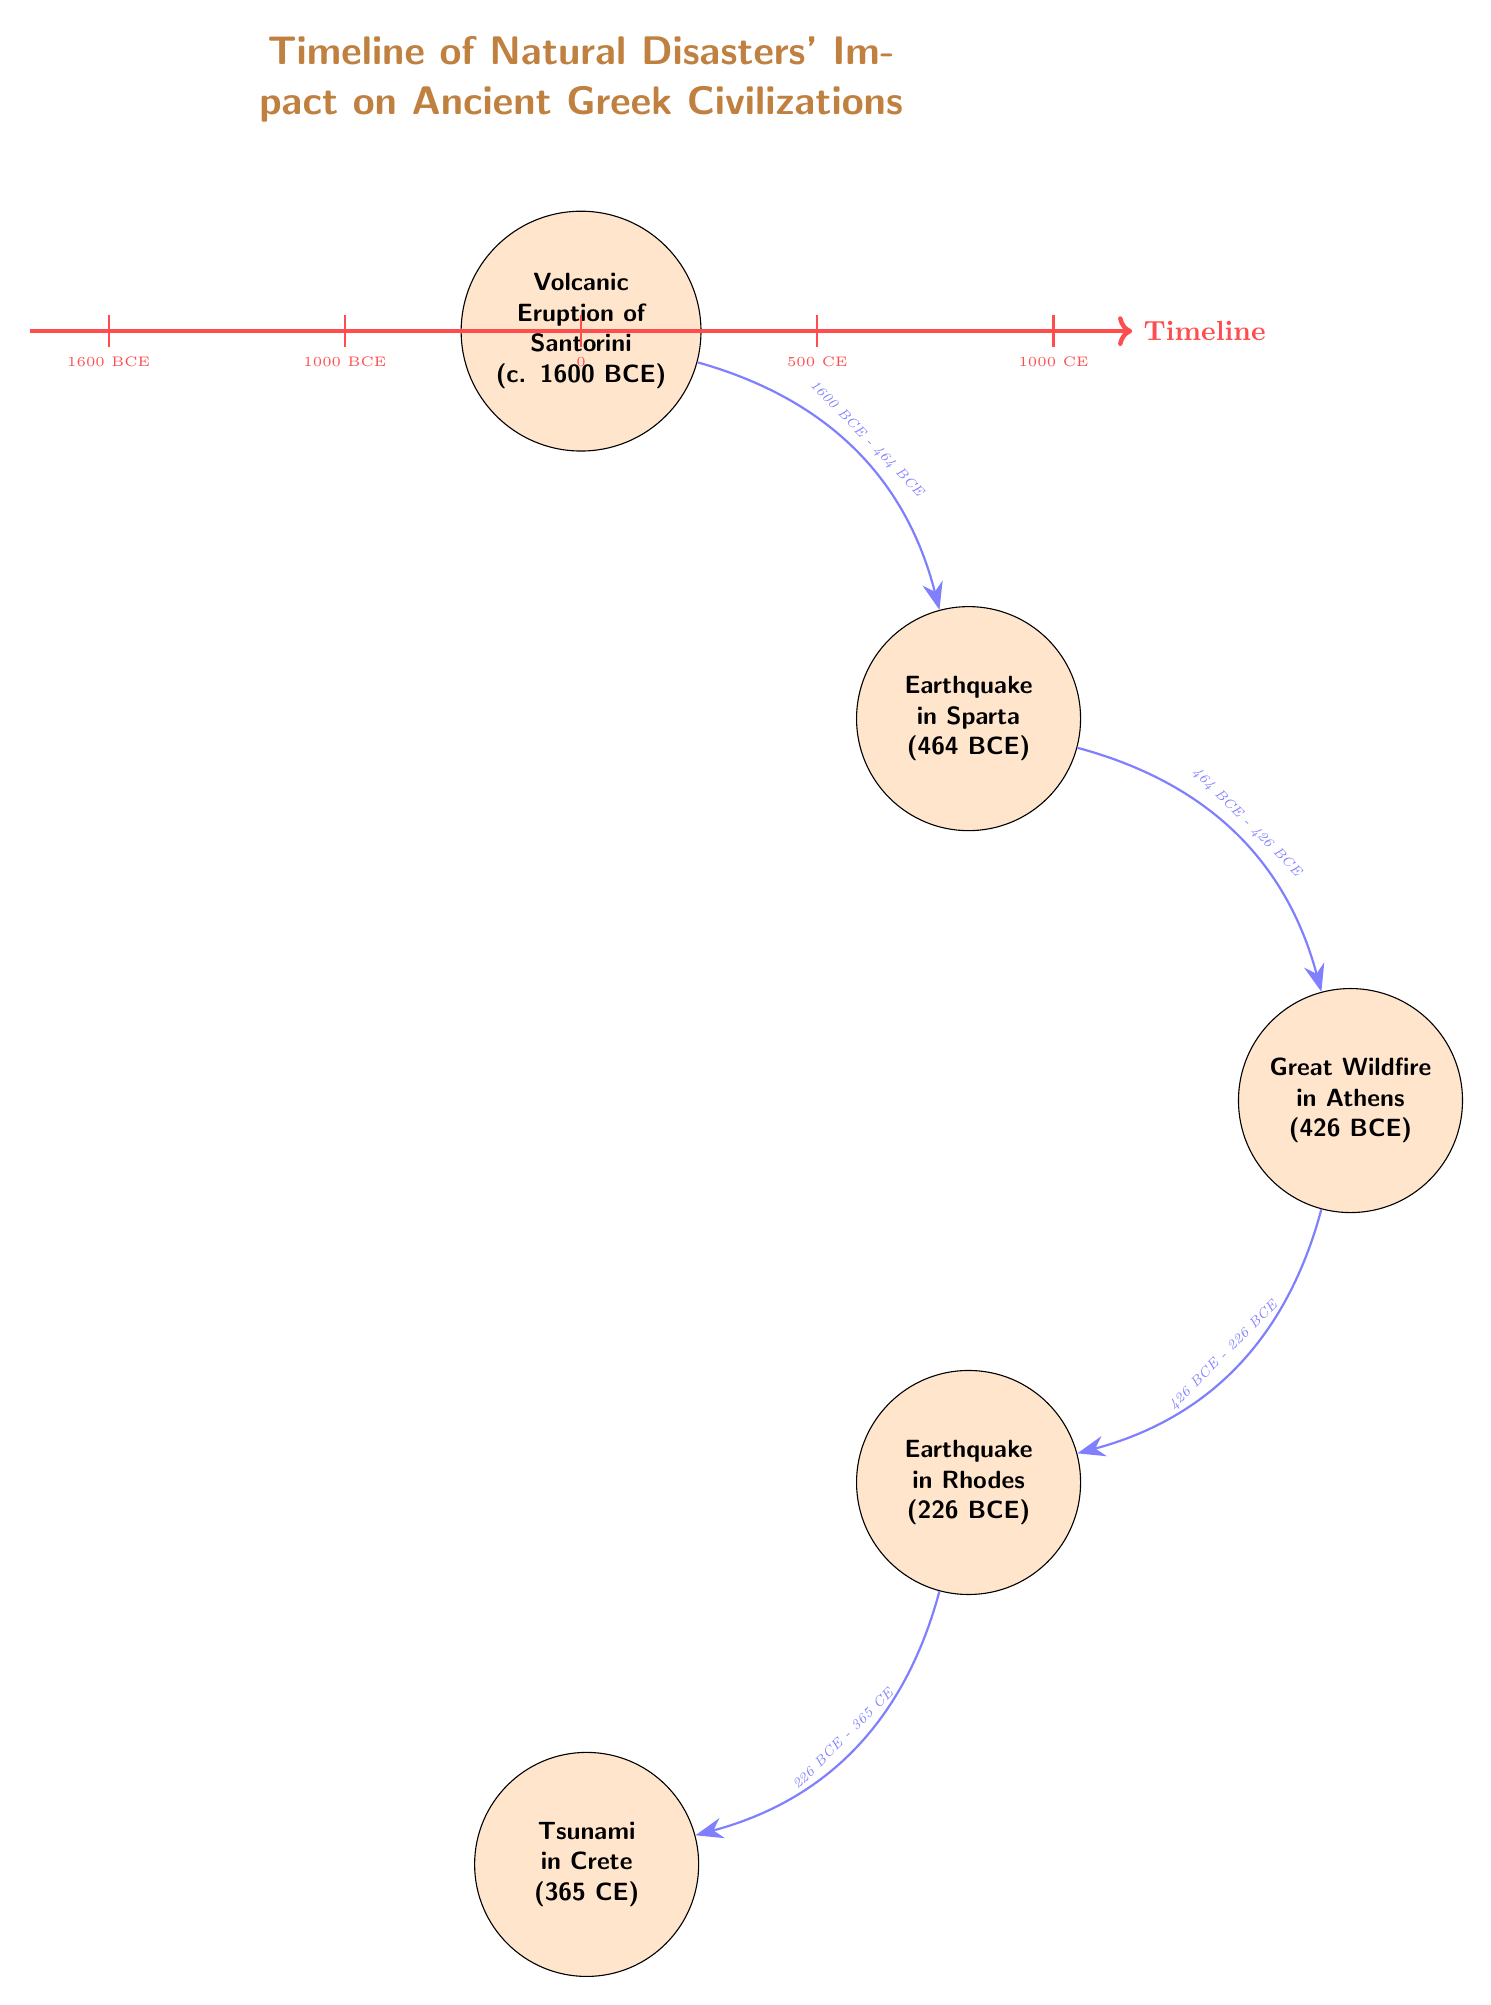What is the event depicted at c. 1600 BCE? The diagram shows a node labeled "Volcanic Eruption of Santorini" at the position corresponding to c. 1600 BCE.
Answer: Volcanic Eruption of Santorini How many events are depicted in the timeline? Counting the nodes in the diagram, there are five distinct events related to natural disasters affecting Ancient Greek civilizations.
Answer: 5 What disaster occurred in 426 BCE? The node for the event at 426 BCE is labeled "Great Wildfire in Athens", indicating the specific disaster that occurred during that year.
Answer: Great Wildfire in Athens Which event occurred immediately after the earthquake in Sparta? The directed arrow from the node "Earthquake in Sparta" points to "Great Wildfire in Athens", indicating that the latter event followed the former in the timeline.
Answer: Great Wildfire in Athens What natural disaster is associated with Crete in 365 CE? The diagram indicates a tsunami event in Crete at 365 CE, as shown in the final node of the flow.
Answer: Tsunami in Crete What is the time span between the Volcanic Eruption of Santorini and the Earthquake in Sparta? The arrows in the diagram clearly represent the flow from the Santorini eruption to the Sparta earthquake, denoting the period from c. 1600 BCE to 464 BCE, which is approximately 1136 years.
Answer: 1136 years Which event occurred in the same century as the Earthquake in Rhodes? The Earthquake in Rhodes is depicted at 226 BCE, and the earlier event "Great Wildfire in Athens" occurred at 426 BCE, making it relevant to identify that no other event shares the same century but they are closely following a timeline structure.
Answer: None In what direction do the arrows of the timeline flow? The arrows in the diagram are drawn to indicate movement from earlier events on the left side to later events on the right side, depicting the progression of time.
Answer: Rightward What event is directly before the Tsunami in Crete? The Tsunami in Crete node is preceded by the "Earthquake in Rhodes" node, as indicated by the arrow showing the timeline's progression.
Answer: Earthquake in Rhodes 